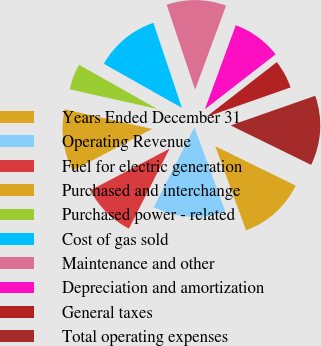<chart> <loc_0><loc_0><loc_500><loc_500><pie_chart><fcel>Years Ended December 31<fcel>Operating Revenue<fcel>Fuel for electric generation<fcel>Purchased and interchange<fcel>Purchased power - related<fcel>Cost of gas sold<fcel>Maintenance and other<fcel>Depreciation and amortization<fcel>General taxes<fcel>Total operating expenses<nl><fcel>12.15%<fcel>13.08%<fcel>9.81%<fcel>11.21%<fcel>4.67%<fcel>11.68%<fcel>10.75%<fcel>8.88%<fcel>5.14%<fcel>12.62%<nl></chart> 